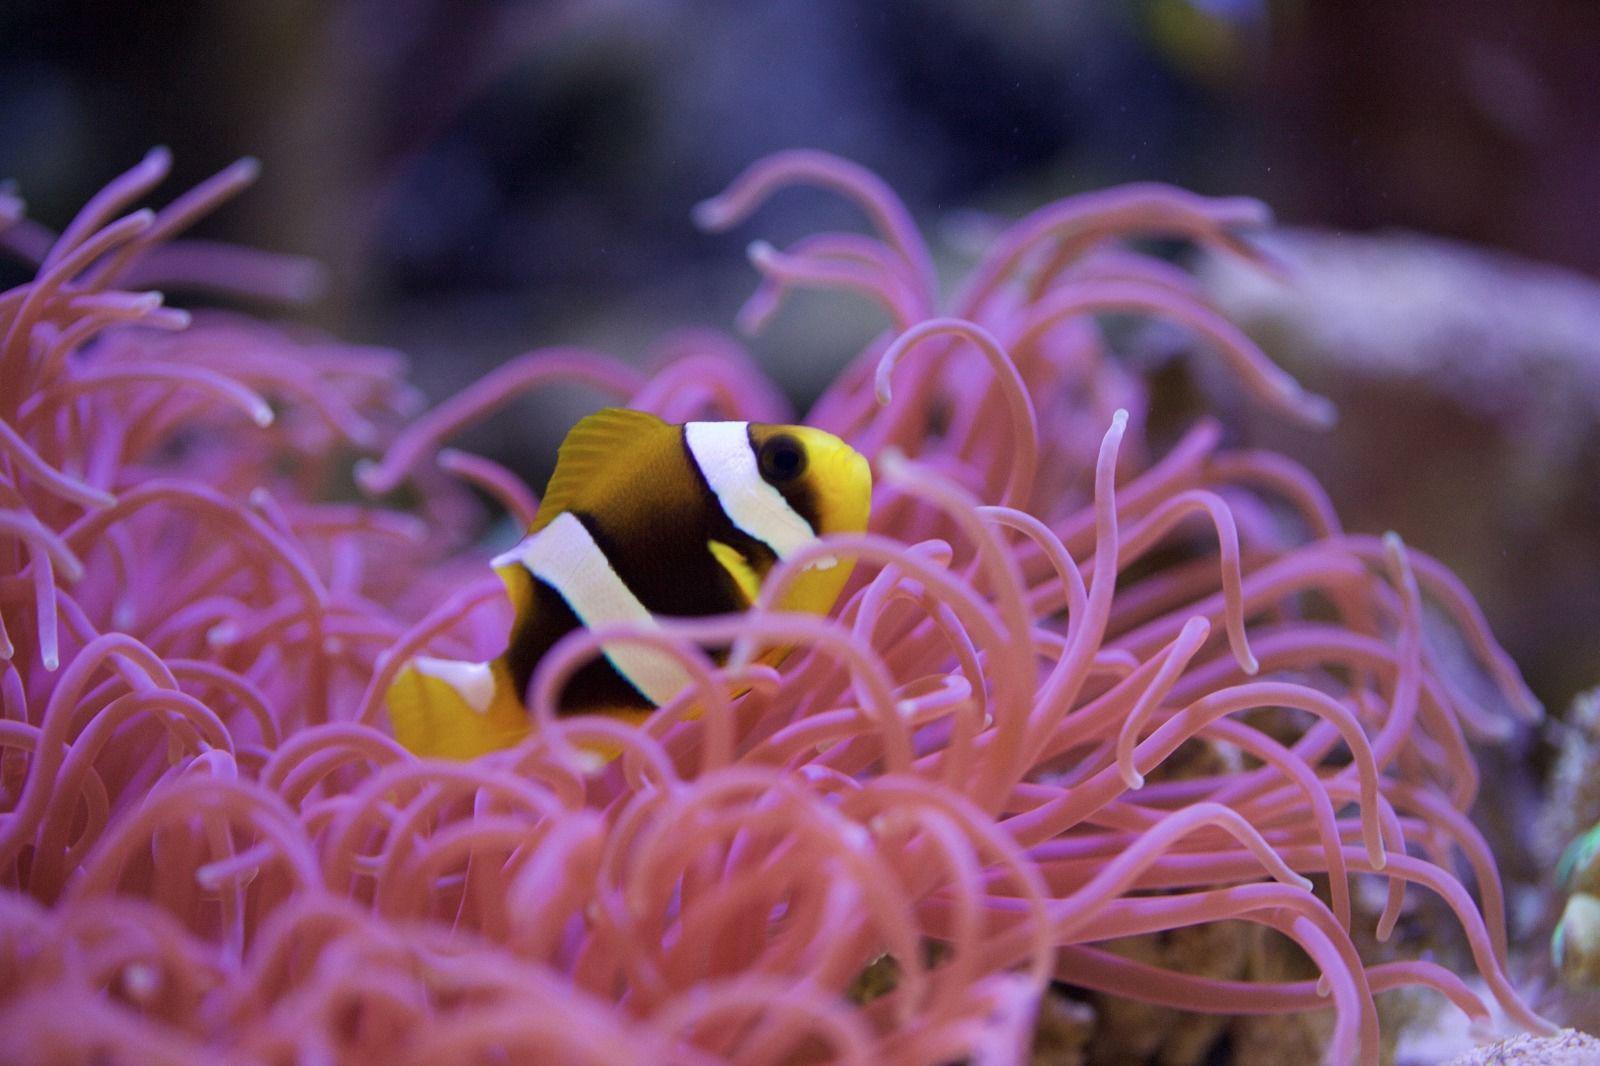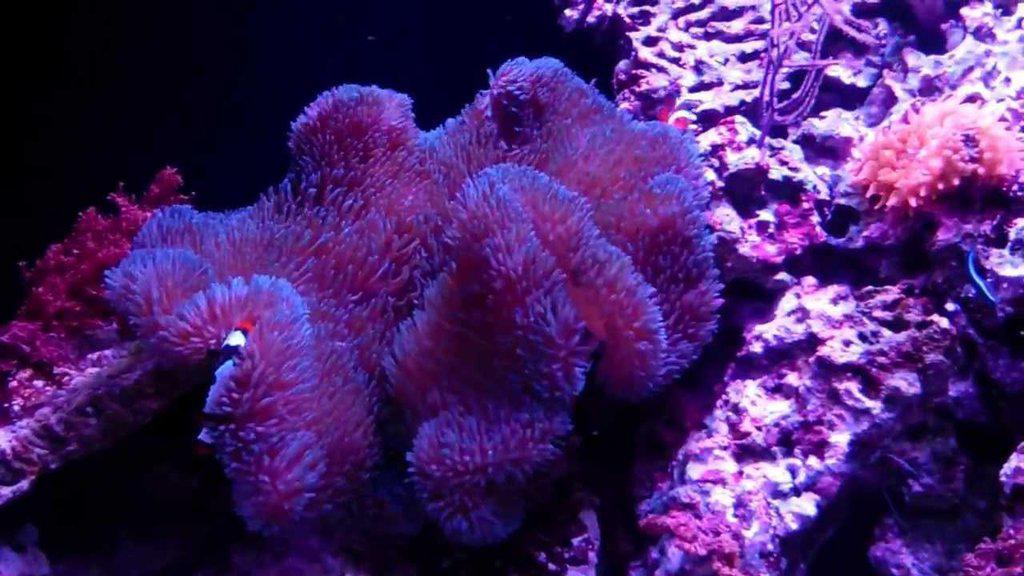The first image is the image on the left, the second image is the image on the right. Evaluate the accuracy of this statement regarding the images: "Only one of the images has a fish in it.". Is it true? Answer yes or no. Yes. The first image is the image on the left, the second image is the image on the right. Evaluate the accuracy of this statement regarding the images: "Right image shows a lavender anemone with plush-looking folds.". Is it true? Answer yes or no. Yes. 